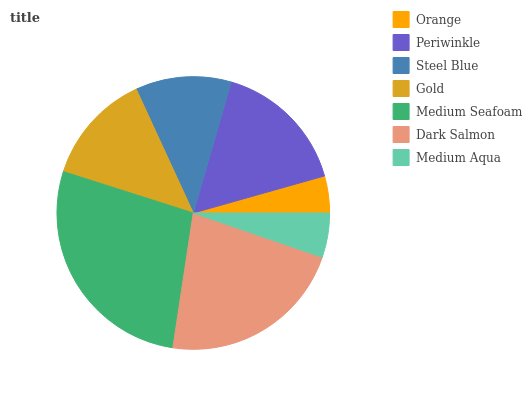Is Orange the minimum?
Answer yes or no. Yes. Is Medium Seafoam the maximum?
Answer yes or no. Yes. Is Periwinkle the minimum?
Answer yes or no. No. Is Periwinkle the maximum?
Answer yes or no. No. Is Periwinkle greater than Orange?
Answer yes or no. Yes. Is Orange less than Periwinkle?
Answer yes or no. Yes. Is Orange greater than Periwinkle?
Answer yes or no. No. Is Periwinkle less than Orange?
Answer yes or no. No. Is Gold the high median?
Answer yes or no. Yes. Is Gold the low median?
Answer yes or no. Yes. Is Periwinkle the high median?
Answer yes or no. No. Is Dark Salmon the low median?
Answer yes or no. No. 